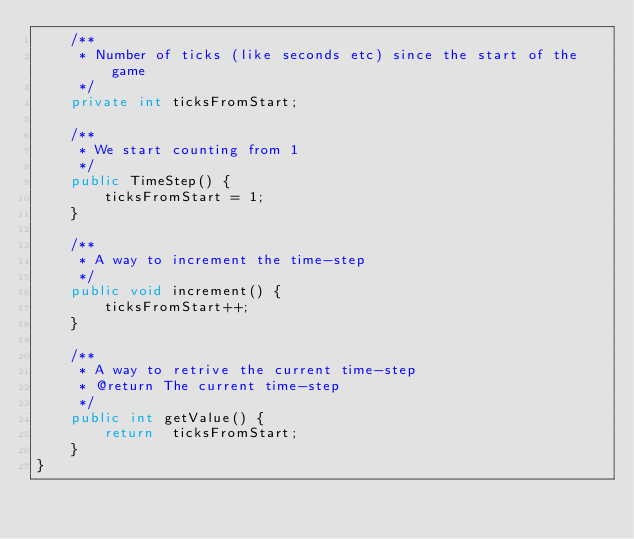Convert code to text. <code><loc_0><loc_0><loc_500><loc_500><_Java_>    /**
     * Number of ticks (like seconds etc) since the start of the game
     */
    private int ticksFromStart;

    /**
     * We start counting from 1
     */
    public TimeStep() {
        ticksFromStart = 1;
    }

    /**
     * A way to increment the time-step
     */
    public void increment() {
        ticksFromStart++;
    }

    /**
     * A way to retrive the current time-step
     * @return The current time-step
     */
    public int getValue() {
        return  ticksFromStart;
    }
}
</code> 